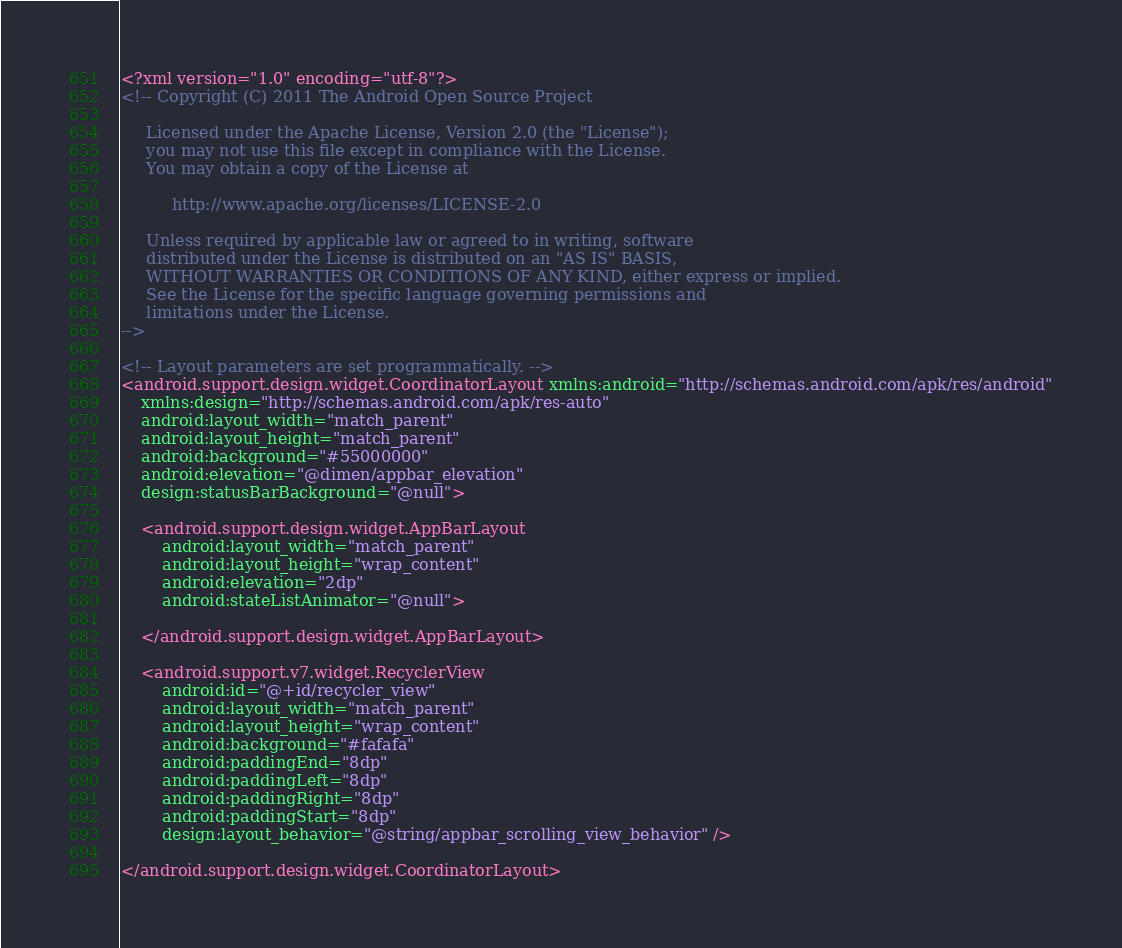<code> <loc_0><loc_0><loc_500><loc_500><_XML_><?xml version="1.0" encoding="utf-8"?>
<!-- Copyright (C) 2011 The Android Open Source Project

     Licensed under the Apache License, Version 2.0 (the "License");
     you may not use this file except in compliance with the License.
     You may obtain a copy of the License at

          http://www.apache.org/licenses/LICENSE-2.0

     Unless required by applicable law or agreed to in writing, software
     distributed under the License is distributed on an "AS IS" BASIS,
     WITHOUT WARRANTIES OR CONDITIONS OF ANY KIND, either express or implied.
     See the License for the specific language governing permissions and
     limitations under the License.
-->

<!-- Layout parameters are set programmatically. -->
<android.support.design.widget.CoordinatorLayout xmlns:android="http://schemas.android.com/apk/res/android"
    xmlns:design="http://schemas.android.com/apk/res-auto"
    android:layout_width="match_parent"
    android:layout_height="match_parent"
    android:background="#55000000"
    android:elevation="@dimen/appbar_elevation"
    design:statusBarBackground="@null">

    <android.support.design.widget.AppBarLayout
        android:layout_width="match_parent"
        android:layout_height="wrap_content"
        android:elevation="2dp"
        android:stateListAnimator="@null">

    </android.support.design.widget.AppBarLayout>

    <android.support.v7.widget.RecyclerView
        android:id="@+id/recycler_view"
        android:layout_width="match_parent"
        android:layout_height="wrap_content"
        android:background="#fafafa"
        android:paddingEnd="8dp"
        android:paddingLeft="8dp"
        android:paddingRight="8dp"
        android:paddingStart="8dp"
        design:layout_behavior="@string/appbar_scrolling_view_behavior" />

</android.support.design.widget.CoordinatorLayout></code> 